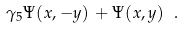Convert formula to latex. <formula><loc_0><loc_0><loc_500><loc_500>\gamma _ { 5 } \Psi ( x , - y ) \, + \Psi ( x , y ) \ .</formula> 